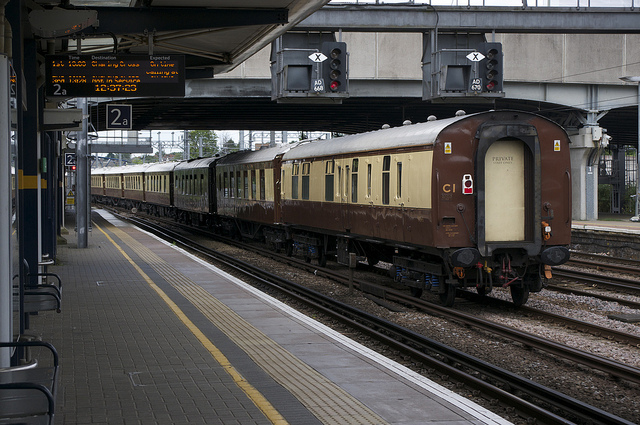Read all the text in this image. CL 2 a 2 2 X X 